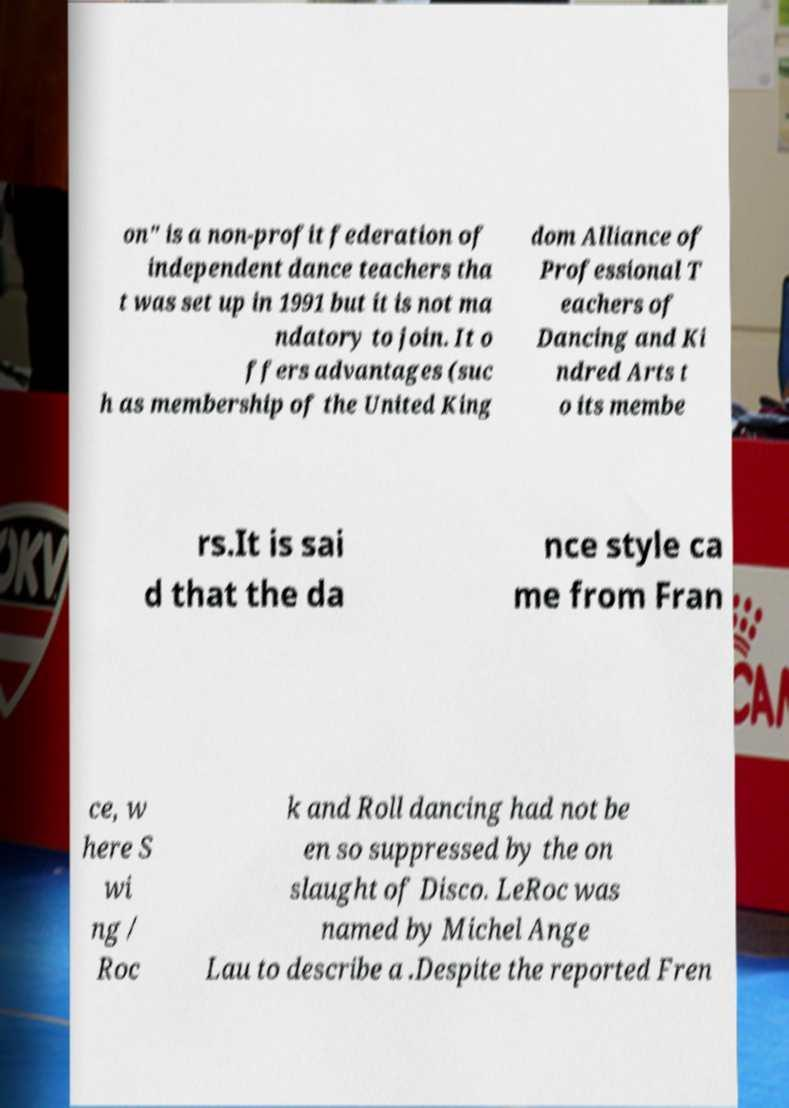Could you assist in decoding the text presented in this image and type it out clearly? on" is a non-profit federation of independent dance teachers tha t was set up in 1991 but it is not ma ndatory to join. It o ffers advantages (suc h as membership of the United King dom Alliance of Professional T eachers of Dancing and Ki ndred Arts t o its membe rs.It is sai d that the da nce style ca me from Fran ce, w here S wi ng / Roc k and Roll dancing had not be en so suppressed by the on slaught of Disco. LeRoc was named by Michel Ange Lau to describe a .Despite the reported Fren 